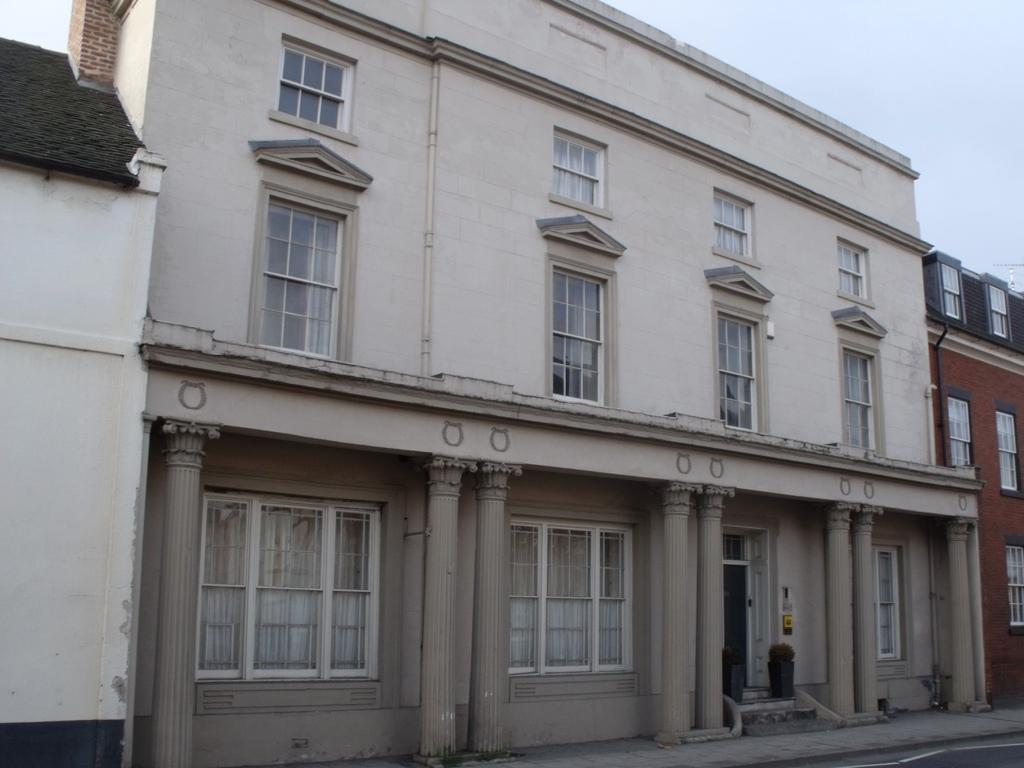What is the main subject in the center of the image? There are buildings in the center of the image. What can be seen in the background of the image? The sky is visible in the background of the image. Is there any quicksand visible in the image? No, there is no quicksand present in the image. What type of fuel is being used by the buildings in the image? The image does not provide any information about the type of fuel being used by the buildings. 